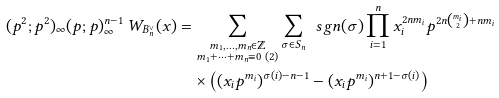Convert formula to latex. <formula><loc_0><loc_0><loc_500><loc_500>( p ^ { 2 } ; p ^ { 2 } ) _ { \infty } ( p ; p ) _ { \infty } ^ { n - 1 } \, W _ { B _ { n } ^ { \vee } } ( x ) & = \sum _ { \substack { m _ { 1 } , \dots , m _ { n } \in \mathbb { Z } \\ m _ { 1 } + \dots + m _ { n } \equiv 0 \ ( 2 ) } } \sum _ { \sigma \in S _ { n } } \, \ s g n ( \sigma ) \prod _ { i = 1 } ^ { n } x _ { i } ^ { 2 n m _ { i } } p ^ { 2 n \binom { m _ { i } } 2 + n m _ { i } } \\ & \quad \times \left ( ( x _ { i } p ^ { m _ { i } } ) ^ { \sigma ( i ) - n - 1 } - ( x _ { i } p ^ { m _ { i } } ) ^ { n + 1 - \sigma ( i ) } \right )</formula> 